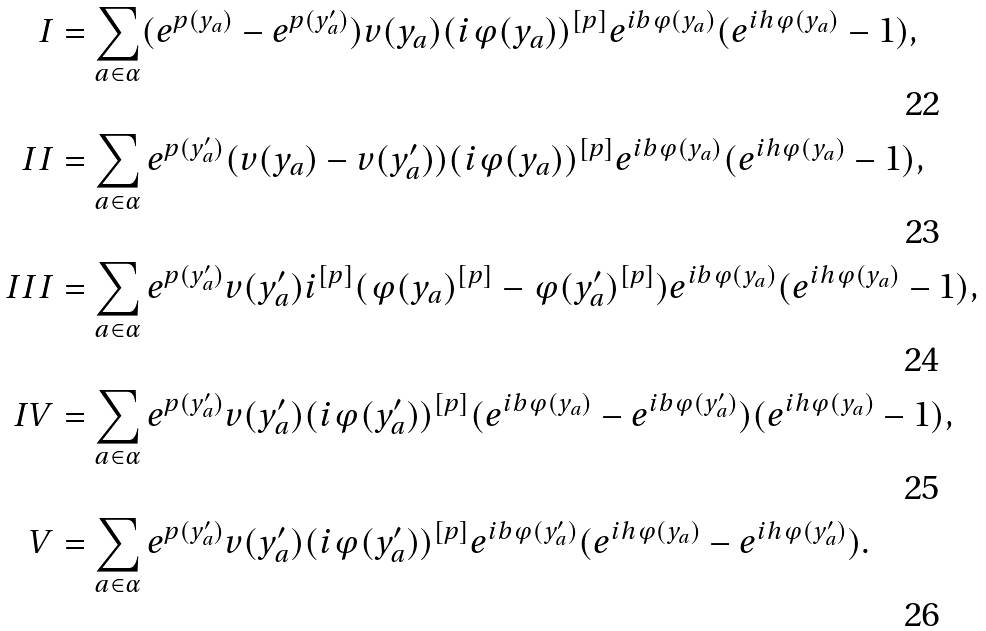<formula> <loc_0><loc_0><loc_500><loc_500>I & = \sum _ { a \in \alpha } ( e ^ { p ( y _ { a } ) } - e ^ { p ( y _ { a } ^ { \prime } ) } ) v ( y _ { a } ) ( i \varphi ( y _ { a } ) ) ^ { [ p ] } e ^ { i b \varphi ( y _ { a } ) } ( e ^ { i h \varphi ( y _ { a } ) } - 1 ) , \\ I I & = \sum _ { a \in \alpha } e ^ { p ( y _ { a } ^ { \prime } ) } ( v ( y _ { a } ) - v ( y _ { a } ^ { \prime } ) ) ( i \varphi ( y _ { a } ) ) ^ { [ p ] } e ^ { i b \varphi ( y _ { a } ) } ( e ^ { i h \varphi ( y _ { a } ) } - 1 ) , \\ I I I & = \sum _ { a \in \alpha } e ^ { p ( y _ { a } ^ { \prime } ) } v ( y _ { a } ^ { \prime } ) i ^ { [ p ] } ( \varphi ( y _ { a } ) ^ { [ p ] } - \varphi ( y _ { a } ^ { \prime } ) ^ { [ p ] } ) e ^ { i b \varphi ( y _ { a } ) } ( e ^ { i h \varphi ( y _ { a } ) } - 1 ) , \\ I V & = \sum _ { a \in \alpha } e ^ { p ( y _ { a } ^ { \prime } ) } v ( y _ { a } ^ { \prime } ) ( i \varphi ( y _ { a } ^ { \prime } ) ) ^ { [ p ] } ( e ^ { i b \varphi ( y _ { a } ) } - e ^ { i b \varphi ( y _ { a } ^ { \prime } ) } ) ( e ^ { i h \varphi ( y _ { a } ) } - 1 ) , \\ V & = \sum _ { a \in \alpha } e ^ { p ( y _ { a } ^ { \prime } ) } v ( y _ { a } ^ { \prime } ) ( i \varphi ( y _ { a } ^ { \prime } ) ) ^ { [ p ] } e ^ { i b \varphi ( y _ { a } ^ { \prime } ) } ( e ^ { i h \varphi ( y _ { a } ) } - e ^ { i h \varphi ( y _ { a } ^ { \prime } ) } ) .</formula> 